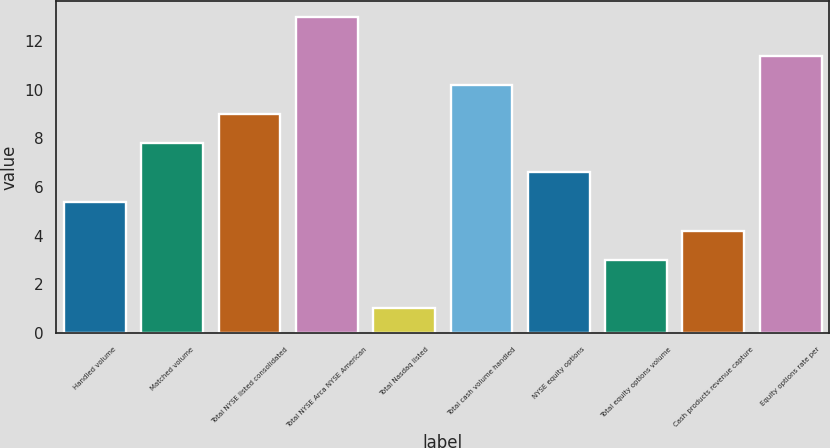Convert chart. <chart><loc_0><loc_0><loc_500><loc_500><bar_chart><fcel>Handled volume<fcel>Matched volume<fcel>Total NYSE listed consolidated<fcel>Total NYSE Arca NYSE American<fcel>Total Nasdaq listed<fcel>Total cash volume handled<fcel>NYSE equity options<fcel>Total equity options volume<fcel>Cash products revenue capture<fcel>Equity options rate per<nl><fcel>5.4<fcel>7.8<fcel>9<fcel>13<fcel>1<fcel>10.2<fcel>6.6<fcel>3<fcel>4.2<fcel>11.4<nl></chart> 